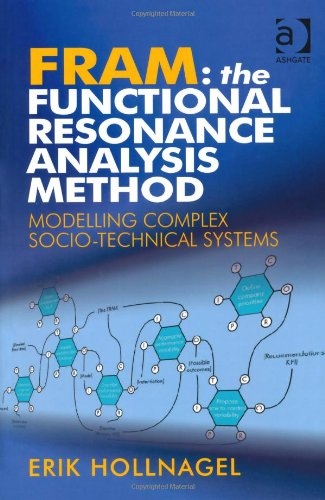Is this book related to Sports & Outdoors? No, this book focuses exclusively on modeling socio-technical systems and does not cover topics related to Sports & Outdoors. 